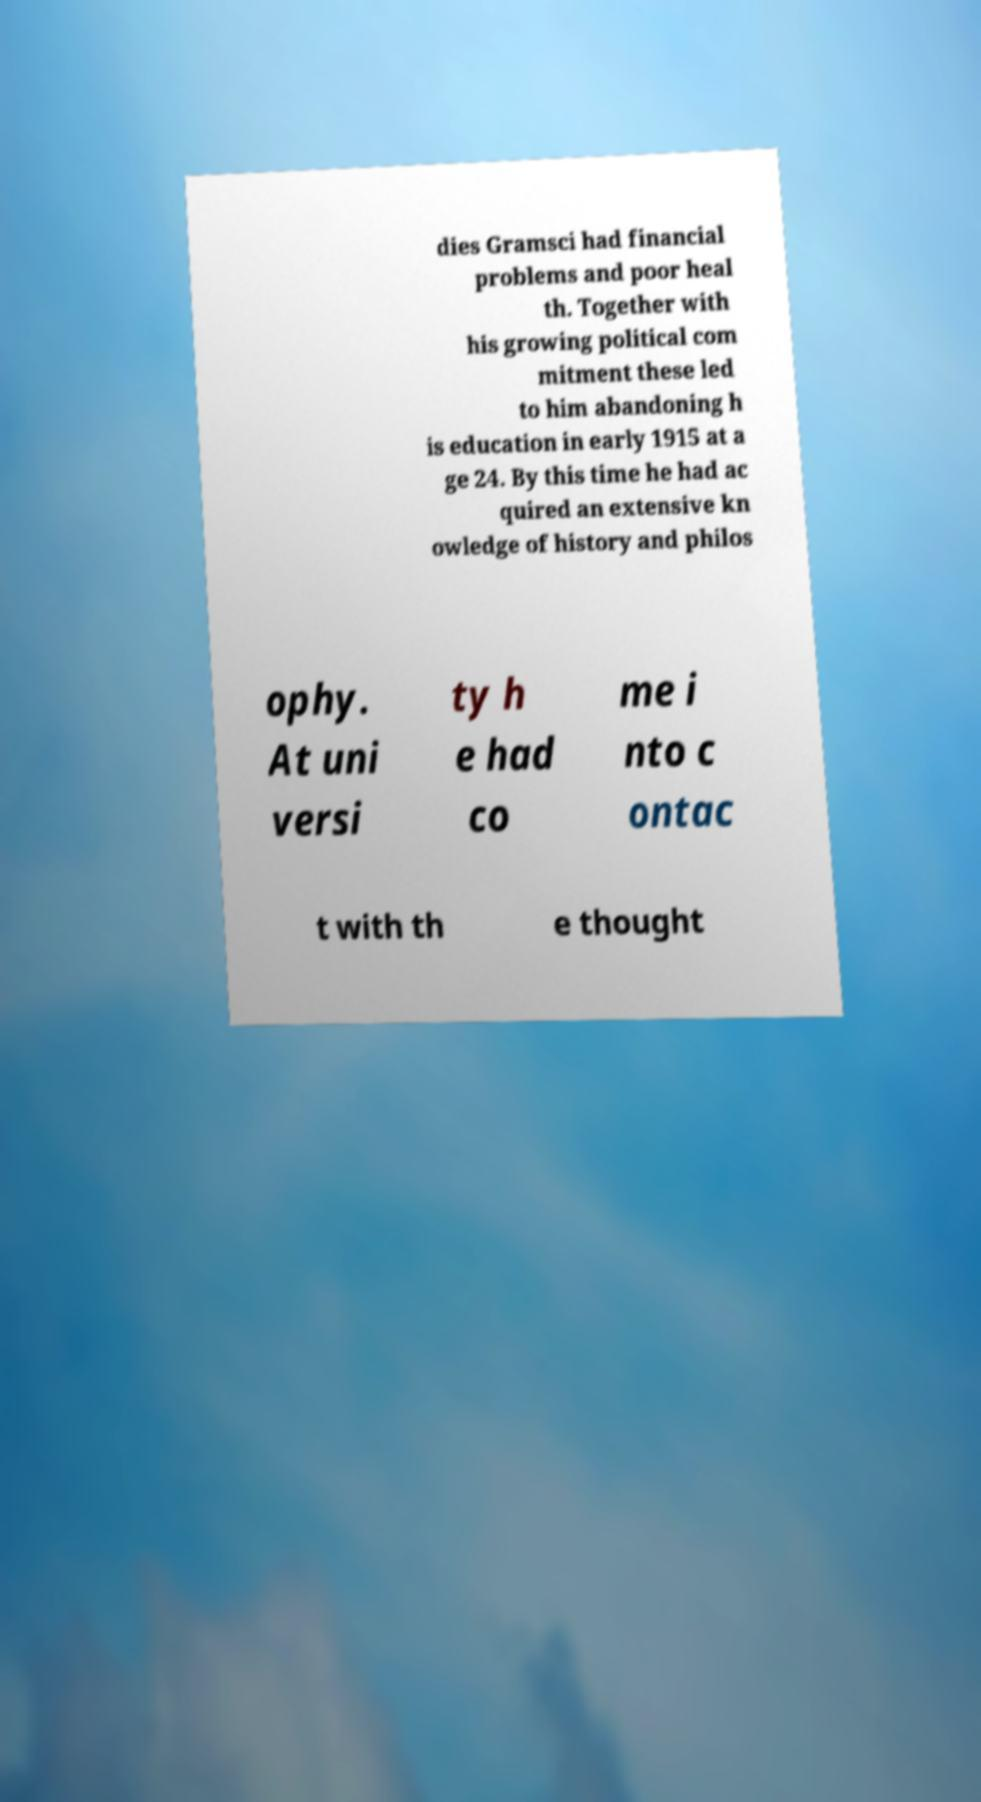Could you assist in decoding the text presented in this image and type it out clearly? dies Gramsci had financial problems and poor heal th. Together with his growing political com mitment these led to him abandoning h is education in early 1915 at a ge 24. By this time he had ac quired an extensive kn owledge of history and philos ophy. At uni versi ty h e had co me i nto c ontac t with th e thought 